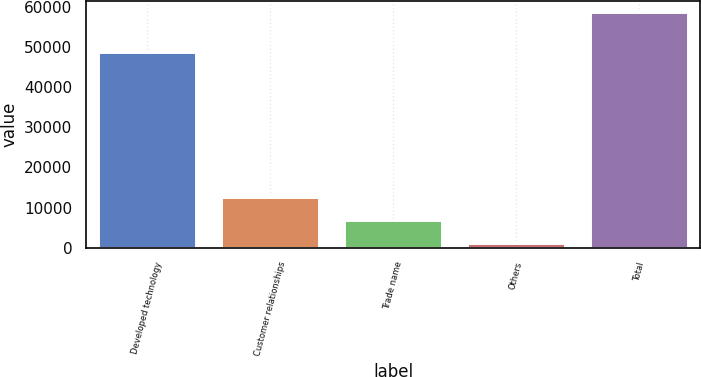<chart> <loc_0><loc_0><loc_500><loc_500><bar_chart><fcel>Developed technology<fcel>Customer relationships<fcel>Trade name<fcel>Others<fcel>Total<nl><fcel>48686<fcel>12552.4<fcel>6795.2<fcel>1038<fcel>58610<nl></chart> 